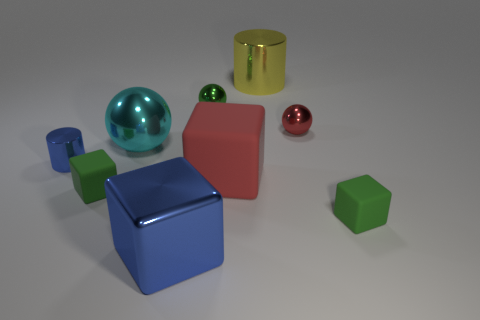What textures can be observed on the various objects in the scene? The objects in the image appear to have matte surfaces with light reflections indicating they have smooth textures typical of metal or plastic materials. 